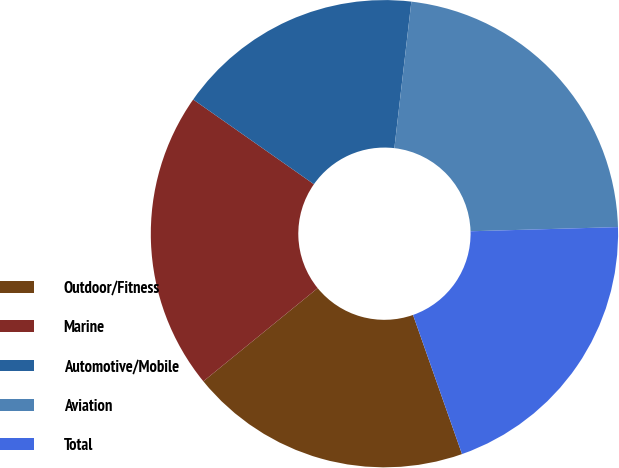<chart> <loc_0><loc_0><loc_500><loc_500><pie_chart><fcel>Outdoor/Fitness<fcel>Marine<fcel>Automotive/Mobile<fcel>Aviation<fcel>Total<nl><fcel>19.5%<fcel>20.62%<fcel>17.1%<fcel>22.71%<fcel>20.06%<nl></chart> 